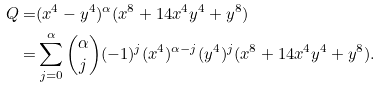<formula> <loc_0><loc_0><loc_500><loc_500>Q = & ( x ^ { 4 } - y ^ { 4 } ) ^ { \alpha } ( x ^ { 8 } + 1 4 x ^ { 4 } y ^ { 4 } + y ^ { 8 } ) \\ = & \sum _ { j = 0 } ^ { \alpha } \binom { \alpha } { j } ( - 1 ) ^ { j } ( x ^ { 4 } ) ^ { \alpha - j } ( y ^ { 4 } ) ^ { j } ( x ^ { 8 } + 1 4 x ^ { 4 } y ^ { 4 } + y ^ { 8 } ) .</formula> 